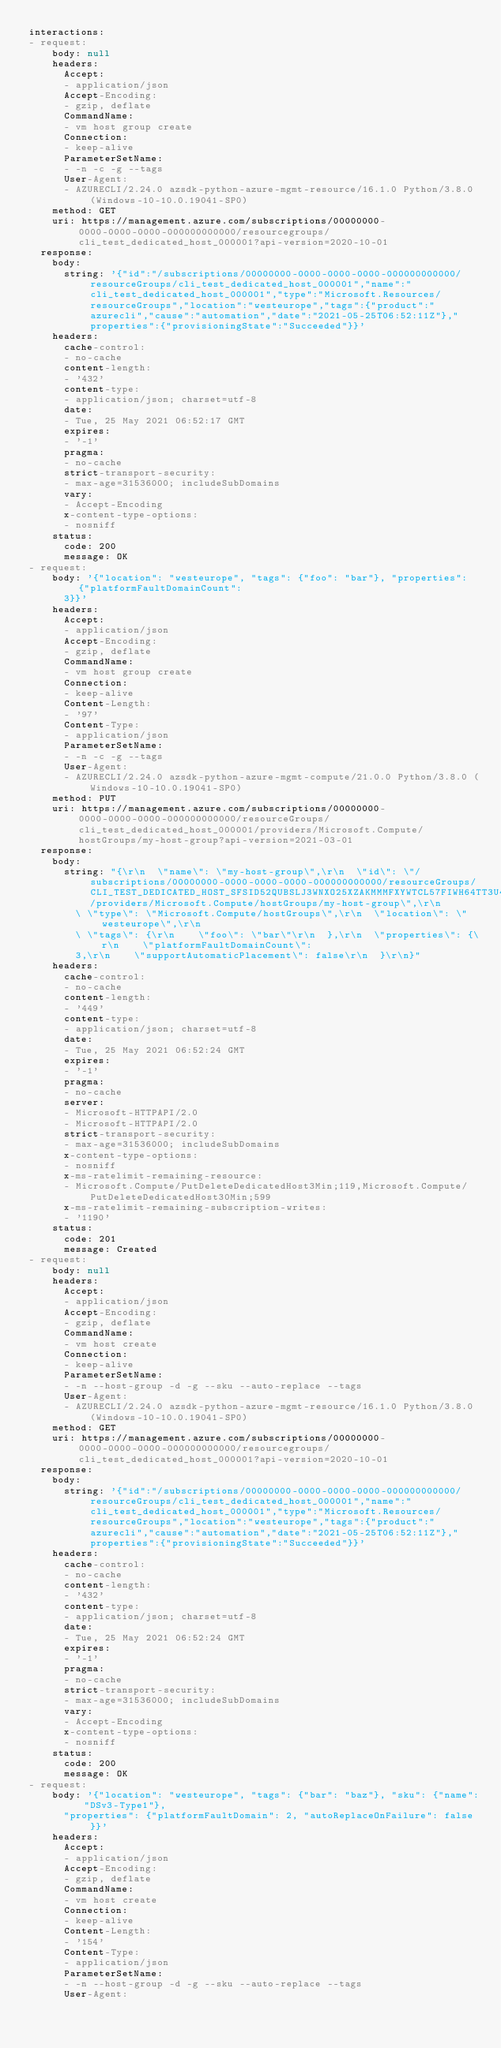<code> <loc_0><loc_0><loc_500><loc_500><_YAML_>interactions:
- request:
    body: null
    headers:
      Accept:
      - application/json
      Accept-Encoding:
      - gzip, deflate
      CommandName:
      - vm host group create
      Connection:
      - keep-alive
      ParameterSetName:
      - -n -c -g --tags
      User-Agent:
      - AZURECLI/2.24.0 azsdk-python-azure-mgmt-resource/16.1.0 Python/3.8.0 (Windows-10-10.0.19041-SP0)
    method: GET
    uri: https://management.azure.com/subscriptions/00000000-0000-0000-0000-000000000000/resourcegroups/cli_test_dedicated_host_000001?api-version=2020-10-01
  response:
    body:
      string: '{"id":"/subscriptions/00000000-0000-0000-0000-000000000000/resourceGroups/cli_test_dedicated_host_000001","name":"cli_test_dedicated_host_000001","type":"Microsoft.Resources/resourceGroups","location":"westeurope","tags":{"product":"azurecli","cause":"automation","date":"2021-05-25T06:52:11Z"},"properties":{"provisioningState":"Succeeded"}}'
    headers:
      cache-control:
      - no-cache
      content-length:
      - '432'
      content-type:
      - application/json; charset=utf-8
      date:
      - Tue, 25 May 2021 06:52:17 GMT
      expires:
      - '-1'
      pragma:
      - no-cache
      strict-transport-security:
      - max-age=31536000; includeSubDomains
      vary:
      - Accept-Encoding
      x-content-type-options:
      - nosniff
    status:
      code: 200
      message: OK
- request:
    body: '{"location": "westeurope", "tags": {"foo": "bar"}, "properties": {"platformFaultDomainCount":
      3}}'
    headers:
      Accept:
      - application/json
      Accept-Encoding:
      - gzip, deflate
      CommandName:
      - vm host group create
      Connection:
      - keep-alive
      Content-Length:
      - '97'
      Content-Type:
      - application/json
      ParameterSetName:
      - -n -c -g --tags
      User-Agent:
      - AZURECLI/2.24.0 azsdk-python-azure-mgmt-compute/21.0.0 Python/3.8.0 (Windows-10-10.0.19041-SP0)
    method: PUT
    uri: https://management.azure.com/subscriptions/00000000-0000-0000-0000-000000000000/resourceGroups/cli_test_dedicated_host_000001/providers/Microsoft.Compute/hostGroups/my-host-group?api-version=2021-03-01
  response:
    body:
      string: "{\r\n  \"name\": \"my-host-group\",\r\n  \"id\": \"/subscriptions/00000000-0000-0000-0000-000000000000/resourceGroups/CLI_TEST_DEDICATED_HOST_SFSID52QUBSLJ3WNXO25XZAKMMMFXYWTCL57FIWH64TT3U4YBU4/providers/Microsoft.Compute/hostGroups/my-host-group\",\r\n
        \ \"type\": \"Microsoft.Compute/hostGroups\",\r\n  \"location\": \"westeurope\",\r\n
        \ \"tags\": {\r\n    \"foo\": \"bar\"\r\n  },\r\n  \"properties\": {\r\n    \"platformFaultDomainCount\":
        3,\r\n    \"supportAutomaticPlacement\": false\r\n  }\r\n}"
    headers:
      cache-control:
      - no-cache
      content-length:
      - '449'
      content-type:
      - application/json; charset=utf-8
      date:
      - Tue, 25 May 2021 06:52:24 GMT
      expires:
      - '-1'
      pragma:
      - no-cache
      server:
      - Microsoft-HTTPAPI/2.0
      - Microsoft-HTTPAPI/2.0
      strict-transport-security:
      - max-age=31536000; includeSubDomains
      x-content-type-options:
      - nosniff
      x-ms-ratelimit-remaining-resource:
      - Microsoft.Compute/PutDeleteDedicatedHost3Min;119,Microsoft.Compute/PutDeleteDedicatedHost30Min;599
      x-ms-ratelimit-remaining-subscription-writes:
      - '1190'
    status:
      code: 201
      message: Created
- request:
    body: null
    headers:
      Accept:
      - application/json
      Accept-Encoding:
      - gzip, deflate
      CommandName:
      - vm host create
      Connection:
      - keep-alive
      ParameterSetName:
      - -n --host-group -d -g --sku --auto-replace --tags
      User-Agent:
      - AZURECLI/2.24.0 azsdk-python-azure-mgmt-resource/16.1.0 Python/3.8.0 (Windows-10-10.0.19041-SP0)
    method: GET
    uri: https://management.azure.com/subscriptions/00000000-0000-0000-0000-000000000000/resourcegroups/cli_test_dedicated_host_000001?api-version=2020-10-01
  response:
    body:
      string: '{"id":"/subscriptions/00000000-0000-0000-0000-000000000000/resourceGroups/cli_test_dedicated_host_000001","name":"cli_test_dedicated_host_000001","type":"Microsoft.Resources/resourceGroups","location":"westeurope","tags":{"product":"azurecli","cause":"automation","date":"2021-05-25T06:52:11Z"},"properties":{"provisioningState":"Succeeded"}}'
    headers:
      cache-control:
      - no-cache
      content-length:
      - '432'
      content-type:
      - application/json; charset=utf-8
      date:
      - Tue, 25 May 2021 06:52:24 GMT
      expires:
      - '-1'
      pragma:
      - no-cache
      strict-transport-security:
      - max-age=31536000; includeSubDomains
      vary:
      - Accept-Encoding
      x-content-type-options:
      - nosniff
    status:
      code: 200
      message: OK
- request:
    body: '{"location": "westeurope", "tags": {"bar": "baz"}, "sku": {"name": "DSv3-Type1"},
      "properties": {"platformFaultDomain": 2, "autoReplaceOnFailure": false}}'
    headers:
      Accept:
      - application/json
      Accept-Encoding:
      - gzip, deflate
      CommandName:
      - vm host create
      Connection:
      - keep-alive
      Content-Length:
      - '154'
      Content-Type:
      - application/json
      ParameterSetName:
      - -n --host-group -d -g --sku --auto-replace --tags
      User-Agent:</code> 